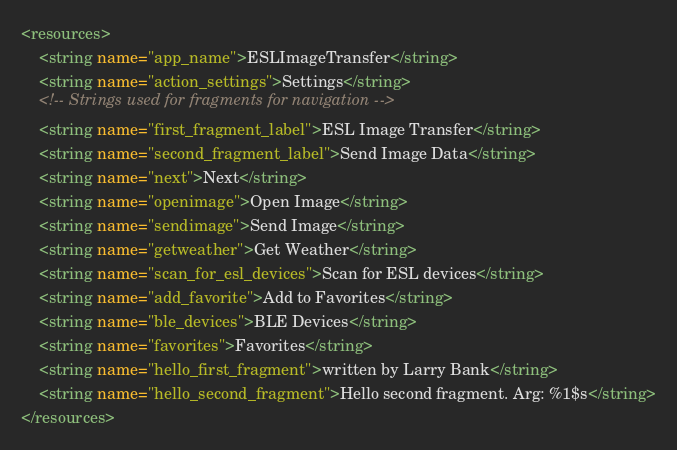Convert code to text. <code><loc_0><loc_0><loc_500><loc_500><_XML_><resources>
    <string name="app_name">ESLImageTransfer</string>
    <string name="action_settings">Settings</string>
    <!-- Strings used for fragments for navigation -->
    <string name="first_fragment_label">ESL Image Transfer</string>
    <string name="second_fragment_label">Send Image Data</string>
    <string name="next">Next</string>
    <string name="openimage">Open Image</string>
    <string name="sendimage">Send Image</string>
    <string name="getweather">Get Weather</string>
    <string name="scan_for_esl_devices">Scan for ESL devices</string>
    <string name="add_favorite">Add to Favorites</string>
    <string name="ble_devices">BLE Devices</string>
    <string name="favorites">Favorites</string>
    <string name="hello_first_fragment">written by Larry Bank</string>
    <string name="hello_second_fragment">Hello second fragment. Arg: %1$s</string>
</resources></code> 